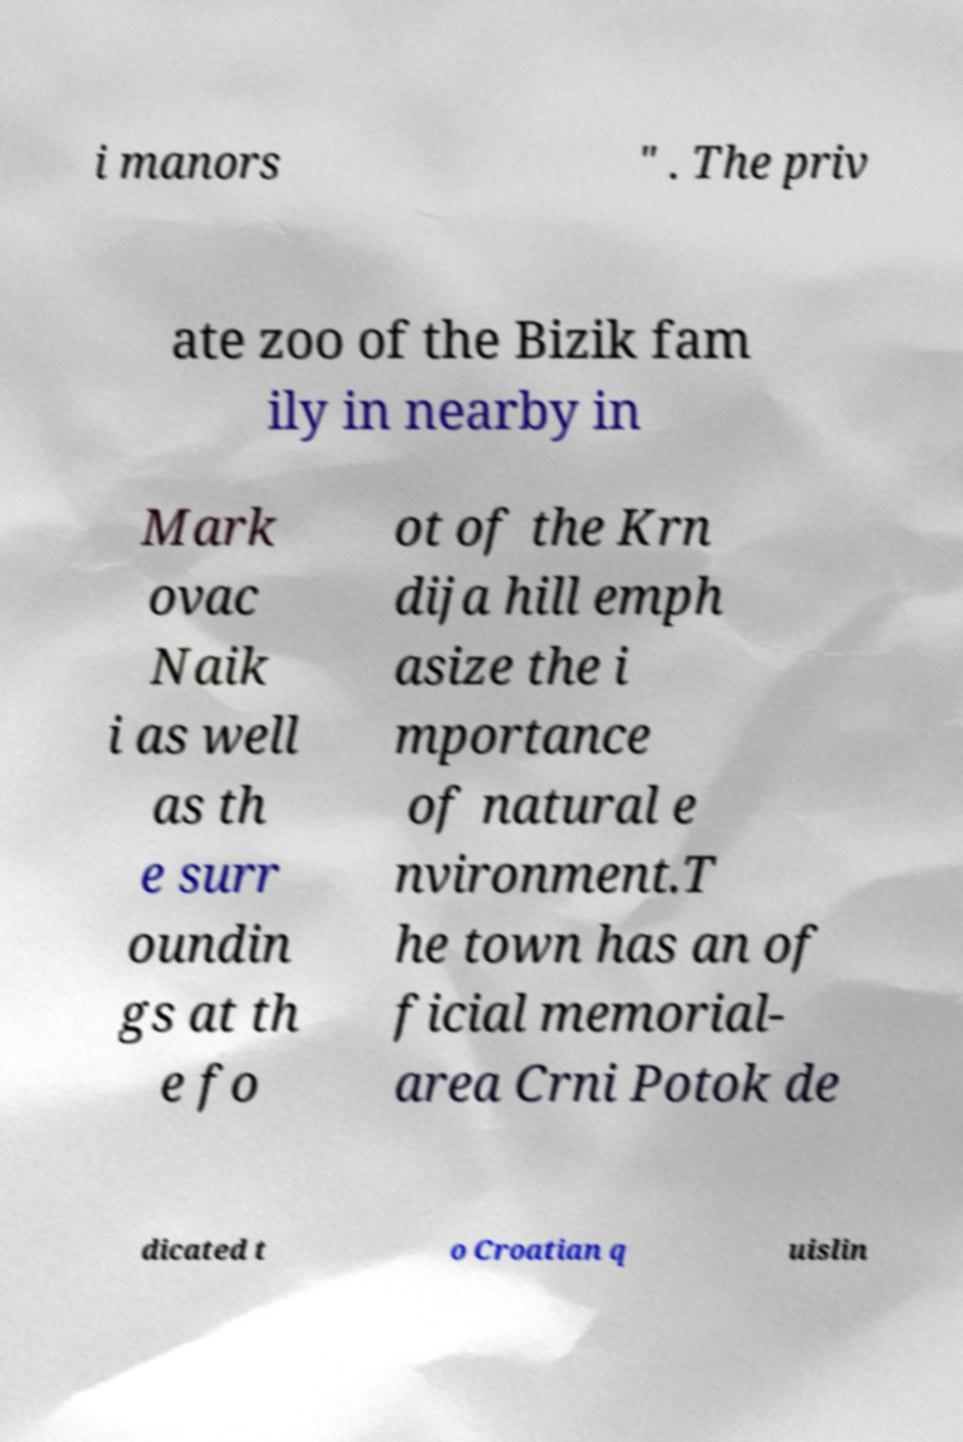For documentation purposes, I need the text within this image transcribed. Could you provide that? i manors " . The priv ate zoo of the Bizik fam ily in nearby in Mark ovac Naik i as well as th e surr oundin gs at th e fo ot of the Krn dija hill emph asize the i mportance of natural e nvironment.T he town has an of ficial memorial- area Crni Potok de dicated t o Croatian q uislin 